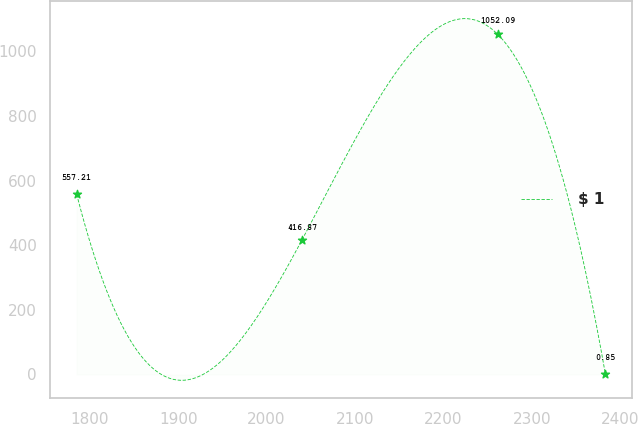Convert chart to OTSL. <chart><loc_0><loc_0><loc_500><loc_500><line_chart><ecel><fcel>$ 1<nl><fcel>1785.24<fcel>557.21<nl><fcel>2040.12<fcel>416.87<nl><fcel>2261.38<fcel>1052.09<nl><fcel>2383.04<fcel>0.85<nl></chart> 